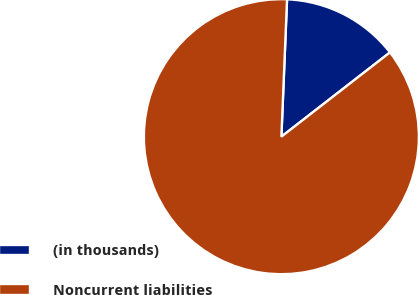Convert chart. <chart><loc_0><loc_0><loc_500><loc_500><pie_chart><fcel>(in thousands)<fcel>Noncurrent liabilities<nl><fcel>13.84%<fcel>86.16%<nl></chart> 